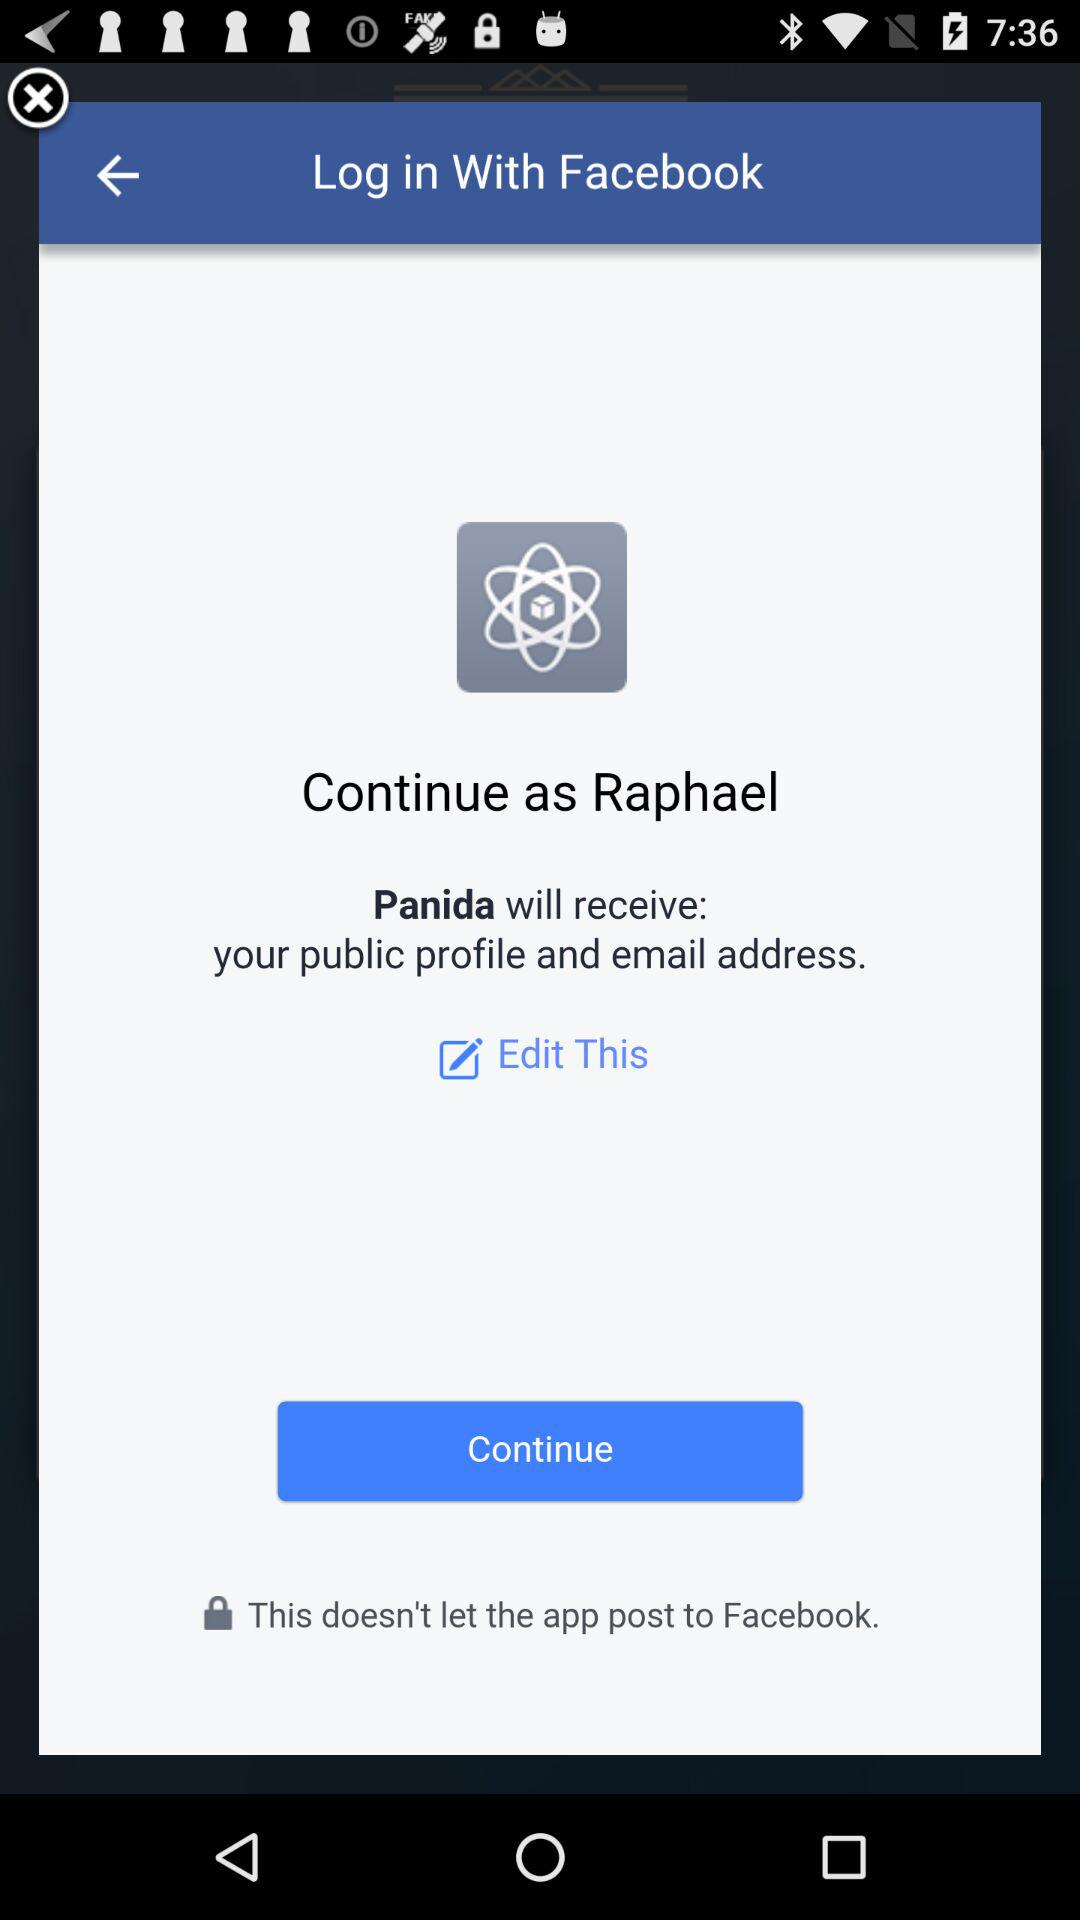What accounts can I use to sign up? You can use "Facebook" to sign up. 